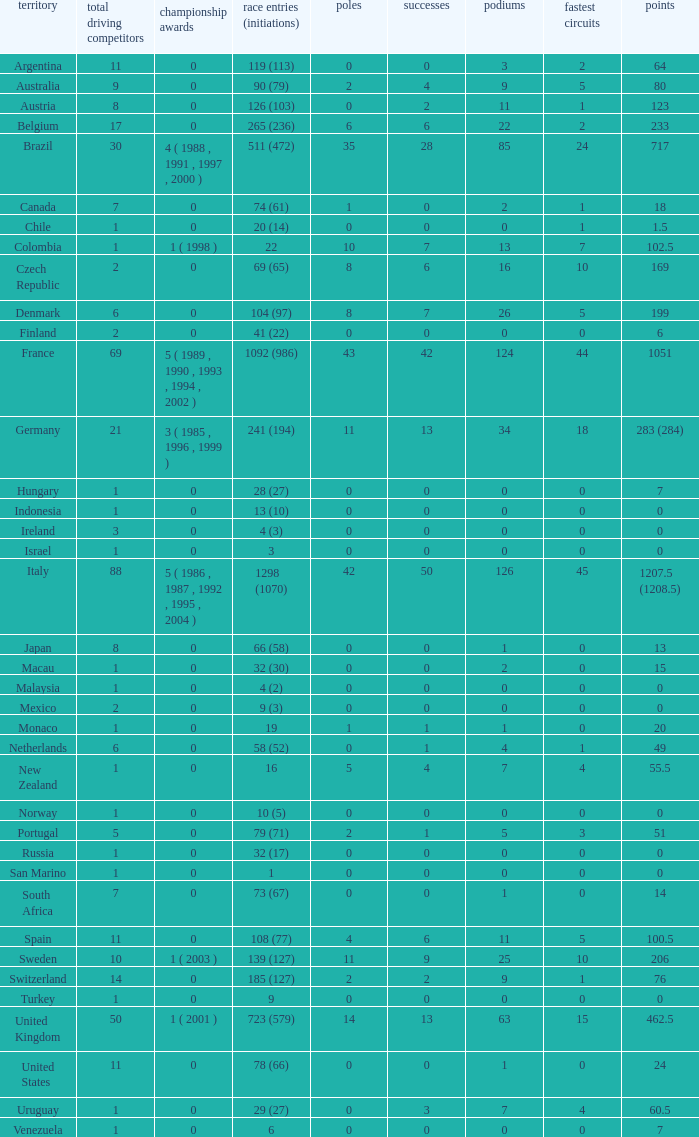How many titles for the nation with less than 3 fastest laps and 22 podiums? 0.0. 